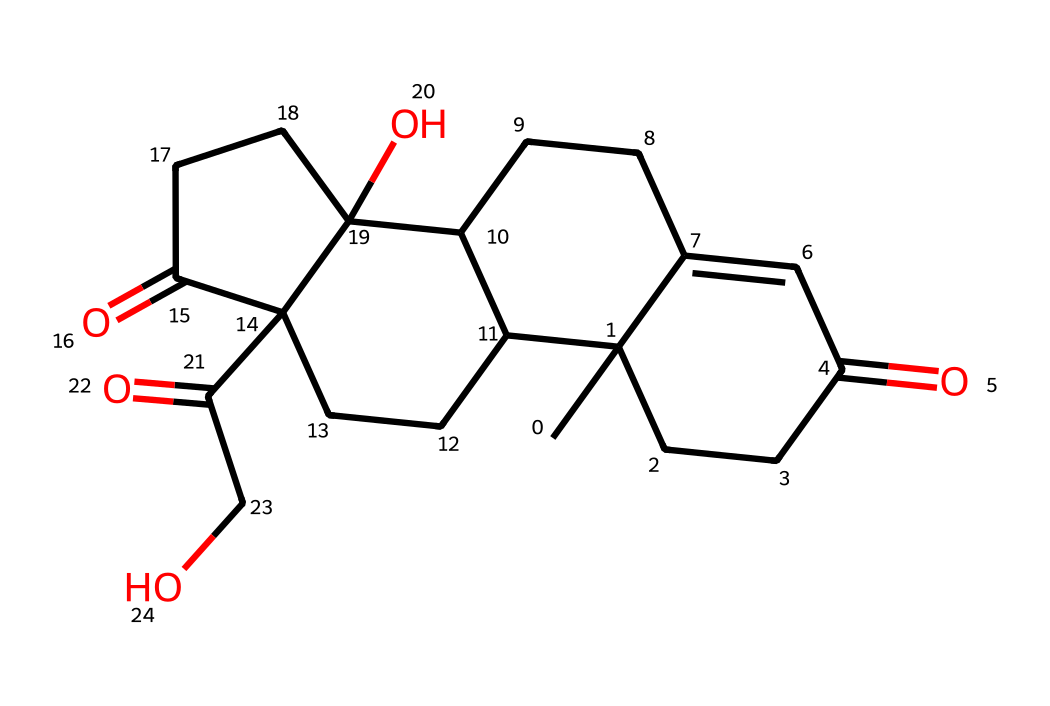What is the molecular formula of cortisol based on its structure? To find the molecular formula, count the number of each type of atom present in the SMILES representation. The structure includes carbon (C), hydrogen (H), and oxygen (O) atoms. In the chemical, there are 21 carbons, 30 hydrogens, and 5 oxygens, leading to the molecular formula C21H30O5.
Answer: C21H30O5 How many rings are present in the structure of cortisol? By analyzing the structure, we can identify the rings based on the connections. The chemical has a fused ring system that comprises four rings. Therefore, the total count of rings is four.
Answer: 4 What types of functional groups are present in cortisol? From the structure, we can identify various functional groups. Cortisol possesses keto groups (C=O), hydroxyl groups (-OH), and a cyclopentanophenanthrene core. Therefore, the main types of functional groups present are ketones and alcohols.
Answer: ketone, alcohol What is the primary role of cortisol in the body? Cortisol is primarily known as a stress hormone that helps to regulate metabolism, control blood sugar levels, and manage the body's response to stress. Thus, the primary role of cortisol is stress response and metabolism regulation.
Answer: stress response What would be the effect of an excess of cortisol in the body? An excess of cortisol can lead to various health issues, including Cushing's syndrome, characterized by symptoms such as weight gain, high blood pressure, and increased risk of infection. Hence, the effect of excess cortisol is Cushing's syndrome.
Answer: Cushing's syndrome How does cortisol respond to stress? Cortisol is released from the adrenal glands when the body perceives stress, triggering a series of physiological responses such as increased energy availability and heightened alertness. Therefore, cortisol responds to stress by increasing energy.
Answer: increasing energy 